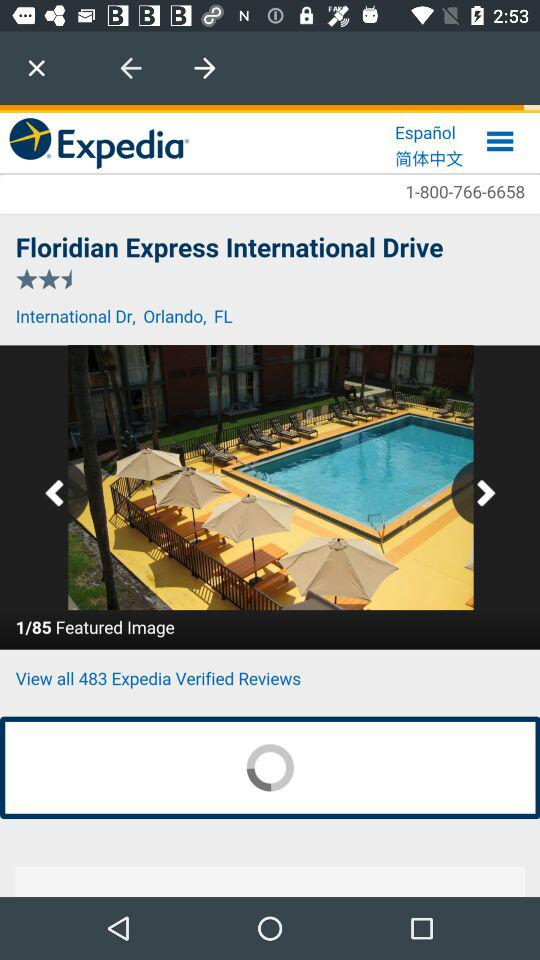How many verified reviews are there? There are 483 verified reviews. 